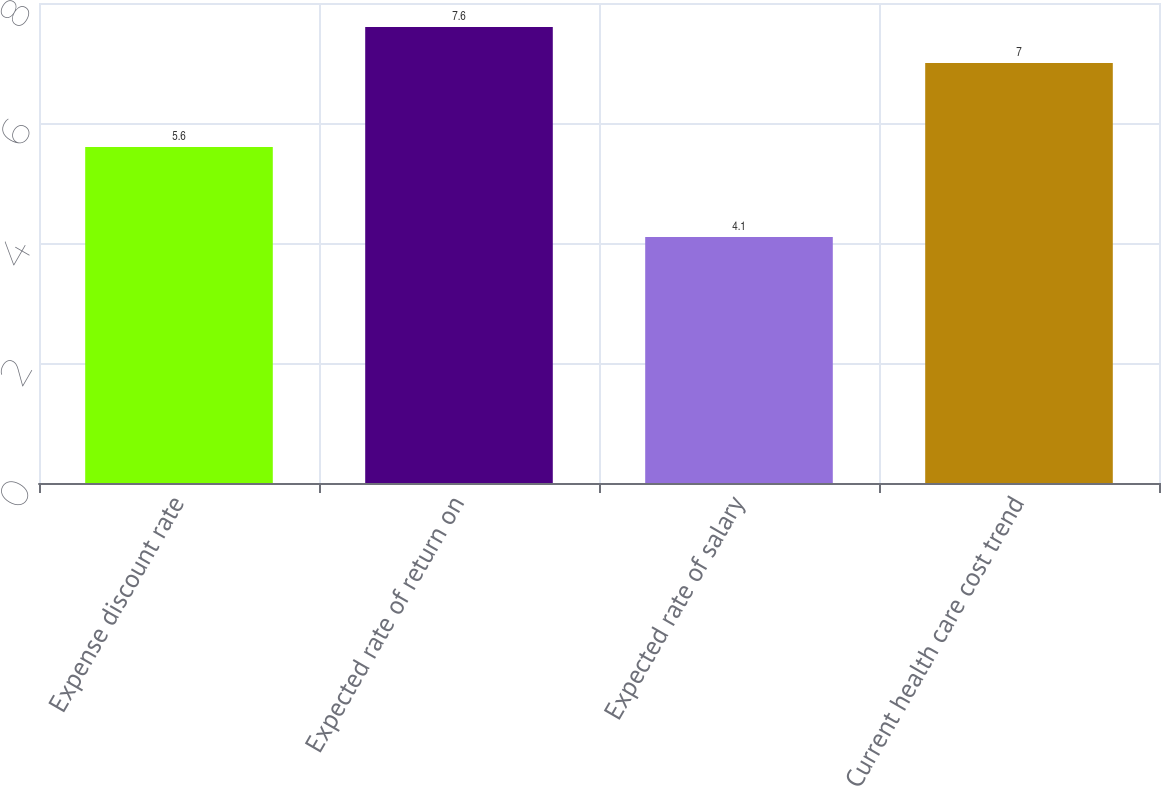Convert chart to OTSL. <chart><loc_0><loc_0><loc_500><loc_500><bar_chart><fcel>Expense discount rate<fcel>Expected rate of return on<fcel>Expected rate of salary<fcel>Current health care cost trend<nl><fcel>5.6<fcel>7.6<fcel>4.1<fcel>7<nl></chart> 